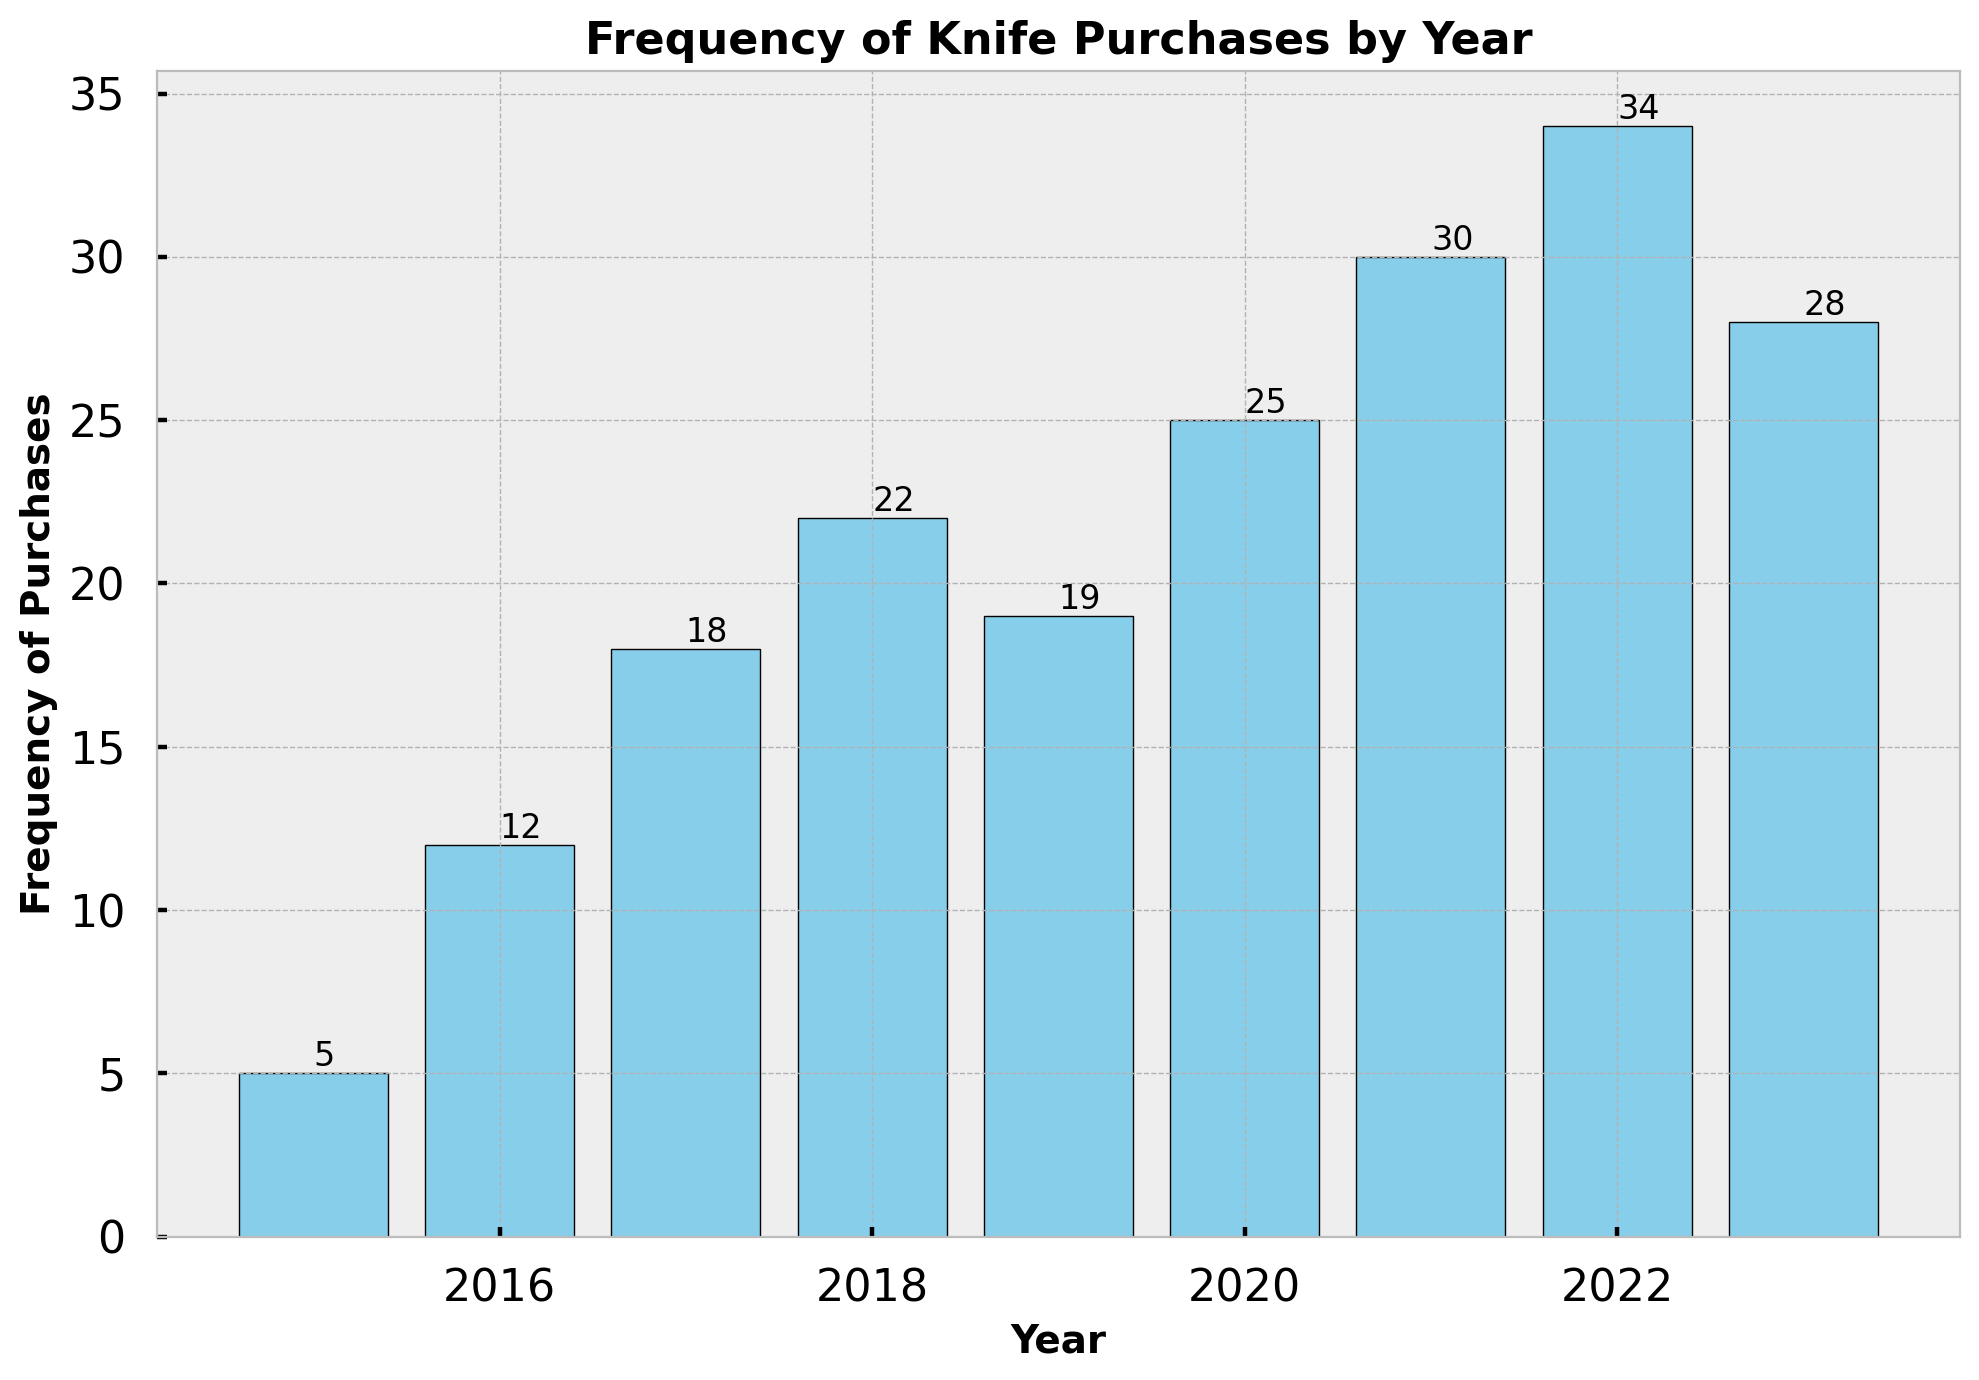Which year had the highest frequency of knife purchases? The bar for 2022 has the highest height, which indicates the highest number of knife purchases.
Answer: 2022 How did the frequency of knife purchases change from 2019 to 2020? The bar for 2020 is taller than the one for 2019. This indicates that the frequency of knife purchases increased from 19 in 2019 to 25 in 2020.
Answer: It increased What is the total frequency of knife purchases from 2016 to 2018? Adding the frequencies from 2016, 2017, and 2018: 12 + 18 + 22 = 52.
Answer: 52 Which year had more purchases, 2018 or 2023? Comparing the heights of the bars for 2018 and 2023, the 2018 bar is taller with a value of 22, whereas the 2023 bar has a value of 28.
Answer: 2023 In which year did the frequency of purchases first exceed 20? The first year where the bar height is greater than 20 is 2018.
Answer: 2018 What is the average frequency of knife purchases for the years 2015, 2016, and 2017? Adding the frequencies for these years gives 5 + 12 + 18 = 35. The average is 35 / 3 ≈ 11.67.
Answer: 11.67 How much higher is the frequency of purchases in 2021 compared to 2019? Subtracting the frequency in 2019 from the frequency in 2021: 30 - 19 = 11.
Answer: 11 higher What is the sum of the frequencies for the years 2020 and 2022? Adding the frequencies for 2020 and 2022: 25 + 34 = 59.
Answer: 59 Which year had a higher increase in the frequency of purchases, 2017 or 2022? Comparing the purchase frequencies for 2017-2018 and 2021-2022: 22 - 18 = 4 for 2017-2018, and 34 - 30 = 4 for 2021-2022. Both have an increase of 4, so they are the same.
Answer: Same What is the difference in the frequency of purchases between the years with the lowest and highest frequencies? The lowest frequency is in 2015 (5 purchases), and the highest is in 2022 (34 purchases). The difference is 34 - 5 = 29.
Answer: 29 